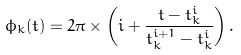<formula> <loc_0><loc_0><loc_500><loc_500>\phi _ { k } ( t ) = 2 \pi \times \left ( i + \frac { t - t _ { k } ^ { i } } { t _ { k } ^ { i + 1 } - t _ { k } ^ { i } } \right ) .</formula> 